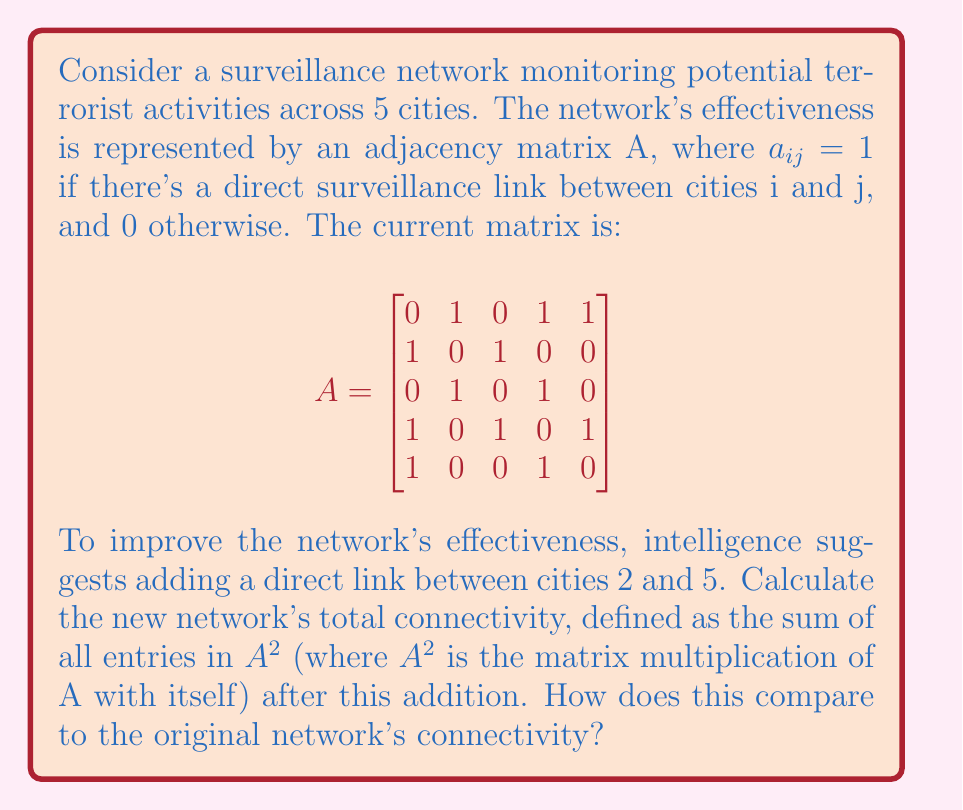Provide a solution to this math problem. 1. First, let's update the adjacency matrix A with the new link between cities 2 and 5:

$$A_{new} = \begin{bmatrix}
0 & 1 & 0 & 1 & 1 \\
1 & 0 & 1 & 0 & 1 \\
0 & 1 & 0 & 1 & 0 \\
1 & 0 & 1 & 0 & 1 \\
1 & 1 & 0 & 1 & 0
\end{bmatrix}$$

2. Now, we need to calculate $A_{new}^2$:

$$A_{new}^2 = \begin{bmatrix}
3 & 1 & 1 & 2 & 1 \\
1 & 3 & 1 & 2 & 1 \\
1 & 1 & 2 & 1 & 2 \\
2 & 2 & 1 & 3 & 1 \\
1 & 1 & 2 & 1 & 3
\end{bmatrix}$$

3. The total connectivity is the sum of all entries in $A_{new}^2$:

$3 + 1 + 1 + 2 + 1 + 1 + 3 + 1 + 2 + 1 + 1 + 1 + 2 + 1 + 2 + 2 + 2 + 1 + 3 + 1 + 1 + 1 + 2 + 1 + 3 = 40$

4. For comparison, let's calculate the original network's connectivity:

$$A^2 = \begin{bmatrix}
3 & 1 & 1 & 2 & 1 \\
1 & 2 & 1 & 2 & 1 \\
1 & 1 & 2 & 1 & 1 \\
2 & 2 & 1 & 3 & 1 \\
1 & 1 & 1 & 1 & 2
\end{bmatrix}$$

The sum of all entries in $A^2$ is 36.

5. The difference in connectivity: $40 - 36 = 4$
Answer: The new network's total connectivity is 40, an increase of 4 from the original network's connectivity of 36. 